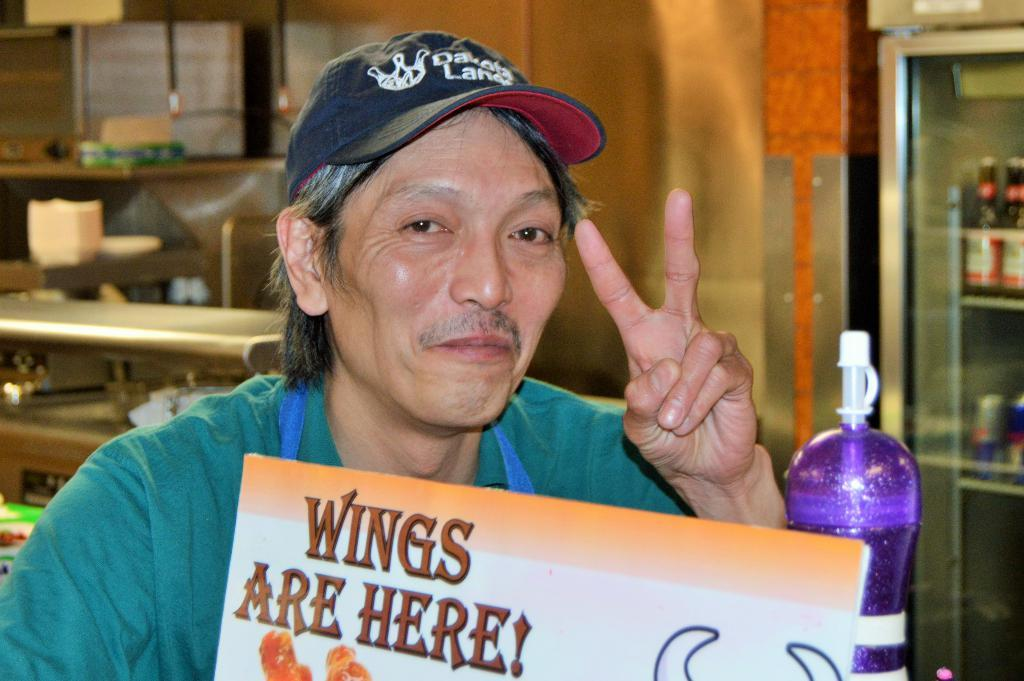Who is present in the image? There is a man in the image. What is the man doing in the image? The man is seated on a chair and smiling. What is the man holding in the image? The man holds a placard in his hand. What else can be seen in the image? There is a bottle visible in the image. What is the man's profit from the competition in the image? There is no mention of profit or competition in the image; it only shows a man seated on a chair, smiling, and holding a placard. What type of toothpaste is the man using in the image? There is no toothpaste present in the image. 